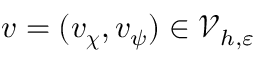<formula> <loc_0><loc_0><loc_500><loc_500>v = ( v _ { \chi } , v _ { \psi } ) \in \mathcal { V } _ { h , \varepsilon }</formula> 